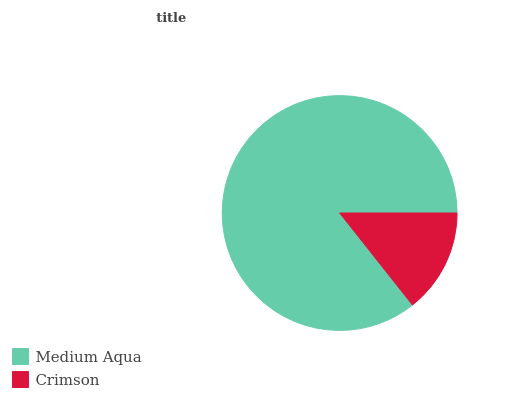Is Crimson the minimum?
Answer yes or no. Yes. Is Medium Aqua the maximum?
Answer yes or no. Yes. Is Crimson the maximum?
Answer yes or no. No. Is Medium Aqua greater than Crimson?
Answer yes or no. Yes. Is Crimson less than Medium Aqua?
Answer yes or no. Yes. Is Crimson greater than Medium Aqua?
Answer yes or no. No. Is Medium Aqua less than Crimson?
Answer yes or no. No. Is Medium Aqua the high median?
Answer yes or no. Yes. Is Crimson the low median?
Answer yes or no. Yes. Is Crimson the high median?
Answer yes or no. No. Is Medium Aqua the low median?
Answer yes or no. No. 